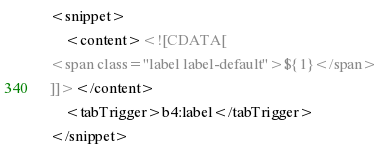Convert code to text. <code><loc_0><loc_0><loc_500><loc_500><_XML_><snippet>
	<content><![CDATA[
<span class="label label-default">${1}</span>
]]></content>
	<tabTrigger>b4:label</tabTrigger>
</snippet>
</code> 